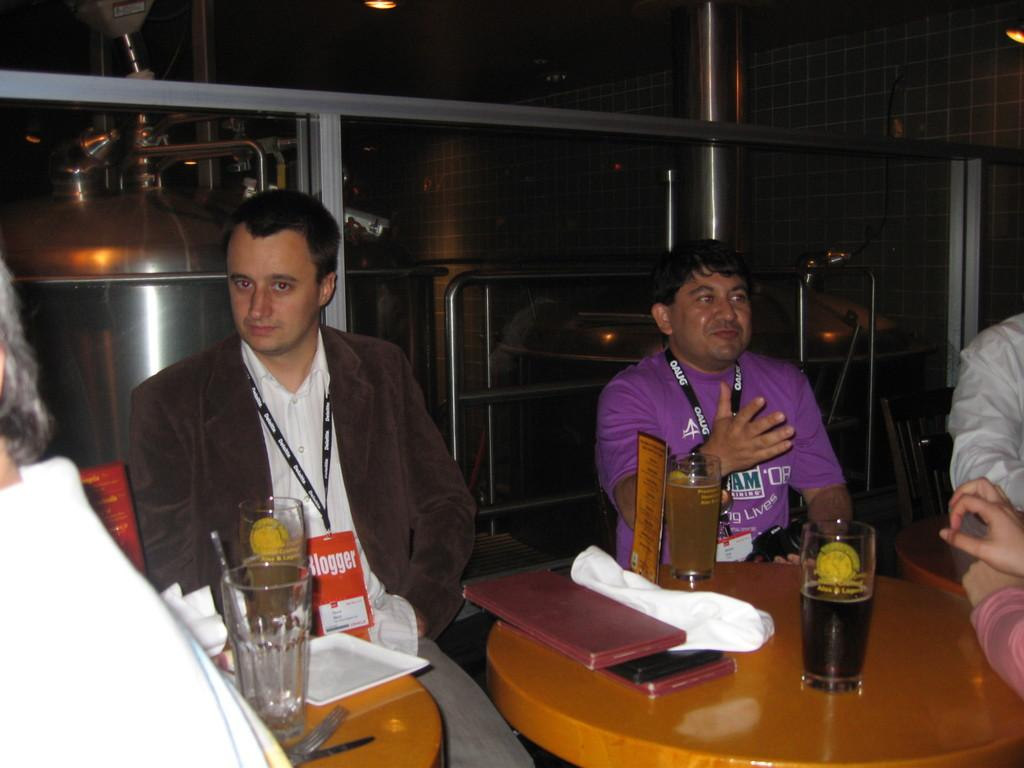Where is the setting of the image? The image is inside a room. What are the people in the image doing? The people are sitting on chairs. What furniture is present in the image? There is a table in the image. What items can be seen on the table? There are glasses, a tray, a book, and a cloth on the table. Can you tell me how many giraffes are in the image? There are no giraffes present in the image. What type of joke is being told by the people in the image? There is no indication of a joke being told in the image; the people are simply sitting on chairs. 